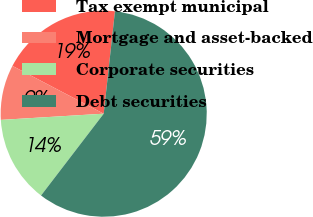Convert chart. <chart><loc_0><loc_0><loc_500><loc_500><pie_chart><fcel>Tax exempt municipal<fcel>Mortgage and asset-backed<fcel>Corporate securities<fcel>Debt securities<nl><fcel>19.06%<fcel>8.64%<fcel>13.64%<fcel>58.66%<nl></chart> 